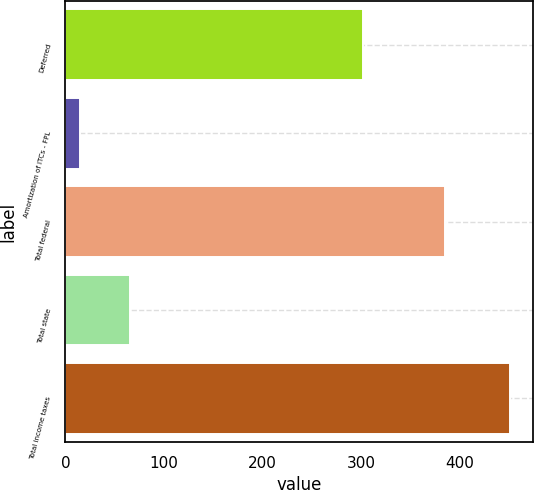<chart> <loc_0><loc_0><loc_500><loc_500><bar_chart><fcel>Deferred<fcel>Amortization of ITCs - FPL<fcel>Total federal<fcel>Total state<fcel>Total income taxes<nl><fcel>302<fcel>15<fcel>385<fcel>66<fcel>451<nl></chart> 